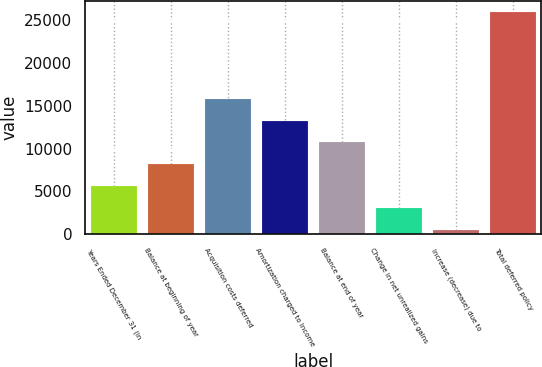Convert chart to OTSL. <chart><loc_0><loc_0><loc_500><loc_500><bar_chart><fcel>Years Ended December 31 (in<fcel>Balance at beginning of year<fcel>Acquisition costs deferred<fcel>Amortization charged to Income<fcel>Balance at end of year<fcel>Change in net unrealized gains<fcel>Increase (decrease) due to<fcel>Total deferred policy<nl><fcel>5619.6<fcel>8166.4<fcel>15806.8<fcel>13260<fcel>10713.2<fcel>3072.8<fcel>526<fcel>25994<nl></chart> 